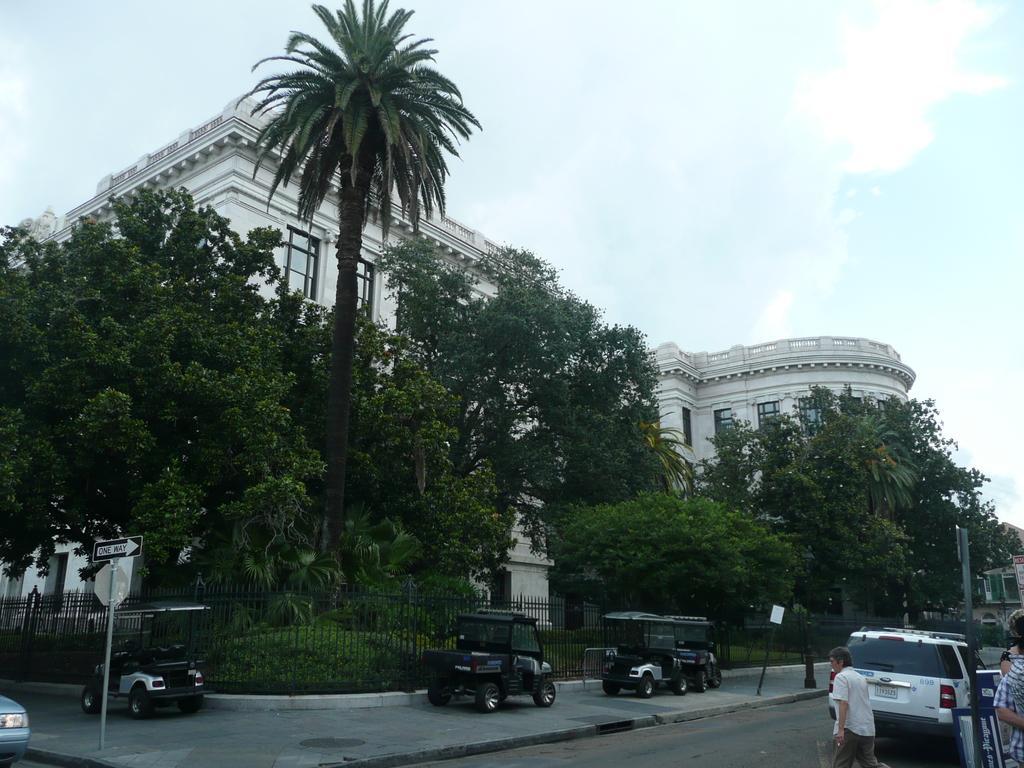Could you give a brief overview of what you see in this image? In this image, there are some trees in front of the building. There are some vehicles at the bottom of the image. There is a person in the bottom right of the image wearing clothes. There is a sky at the top of the image. 